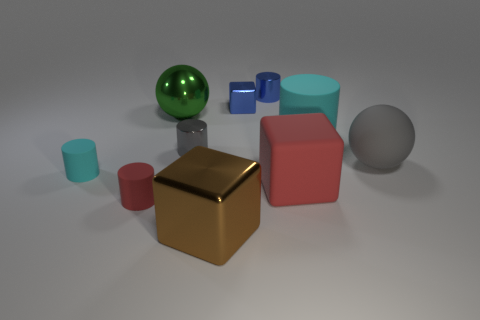Subtract all large cyan rubber cylinders. How many cylinders are left? 4 Subtract all red cylinders. How many cylinders are left? 4 Subtract all green cylinders. Subtract all purple blocks. How many cylinders are left? 5 Subtract all spheres. How many objects are left? 8 Add 9 red cubes. How many red cubes exist? 10 Subtract 1 red cubes. How many objects are left? 9 Subtract all metal cubes. Subtract all big cubes. How many objects are left? 6 Add 1 big rubber cylinders. How many big rubber cylinders are left? 2 